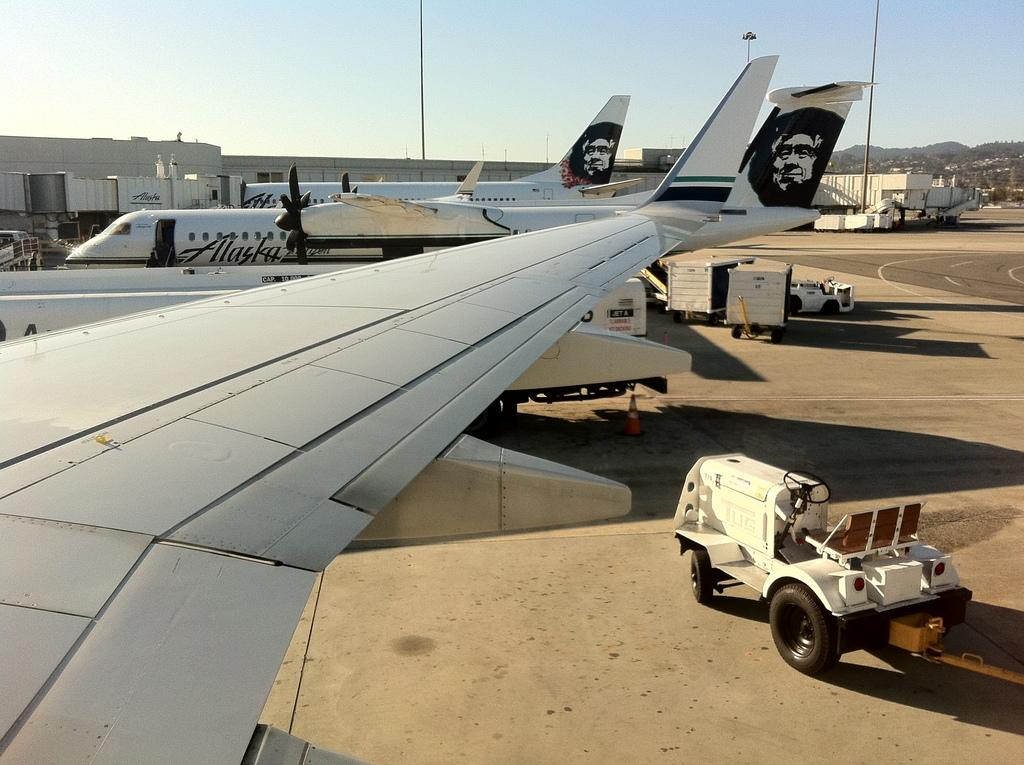What can be seen on the runway in the image? There are aeroplanes on the runway in the image. What other vehicle is present near the aeroplanes? There is a luggage vehicle beside the aeroplanes. What can be seen in the distance behind the aeroplanes? There are mountains visible in the background. What type of face can be seen on the donkey in the image? There is no donkey present in the image, so it is not possible to determine if there is a face on it. 